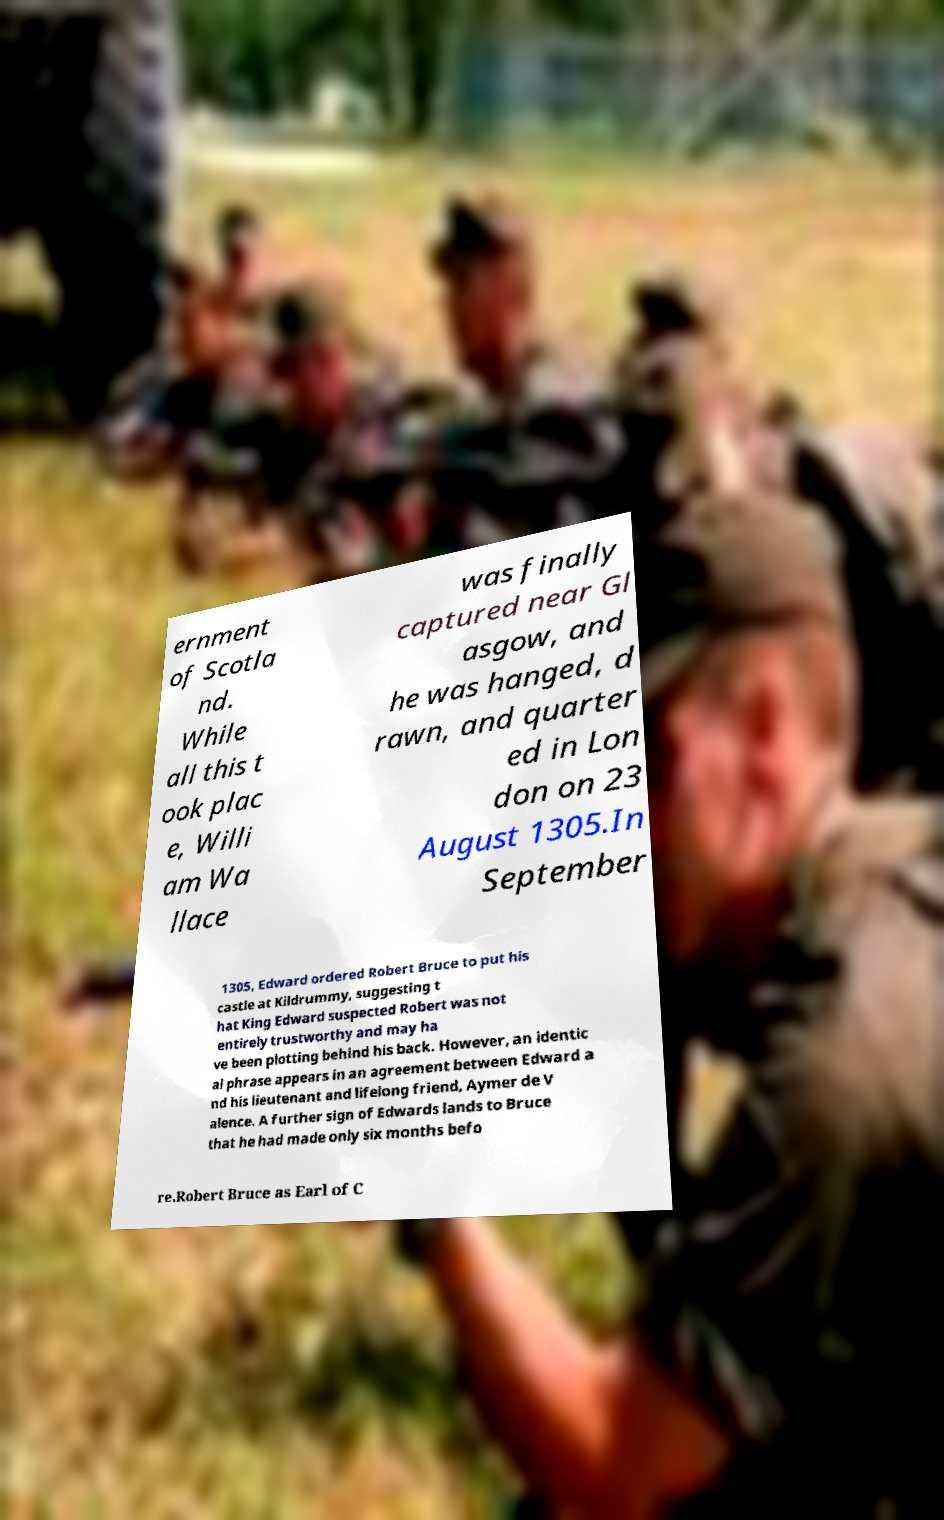Can you accurately transcribe the text from the provided image for me? ernment of Scotla nd. While all this t ook plac e, Willi am Wa llace was finally captured near Gl asgow, and he was hanged, d rawn, and quarter ed in Lon don on 23 August 1305.In September 1305, Edward ordered Robert Bruce to put his castle at Kildrummy, suggesting t hat King Edward suspected Robert was not entirely trustworthy and may ha ve been plotting behind his back. However, an identic al phrase appears in an agreement between Edward a nd his lieutenant and lifelong friend, Aymer de V alence. A further sign of Edwards lands to Bruce that he had made only six months befo re.Robert Bruce as Earl of C 